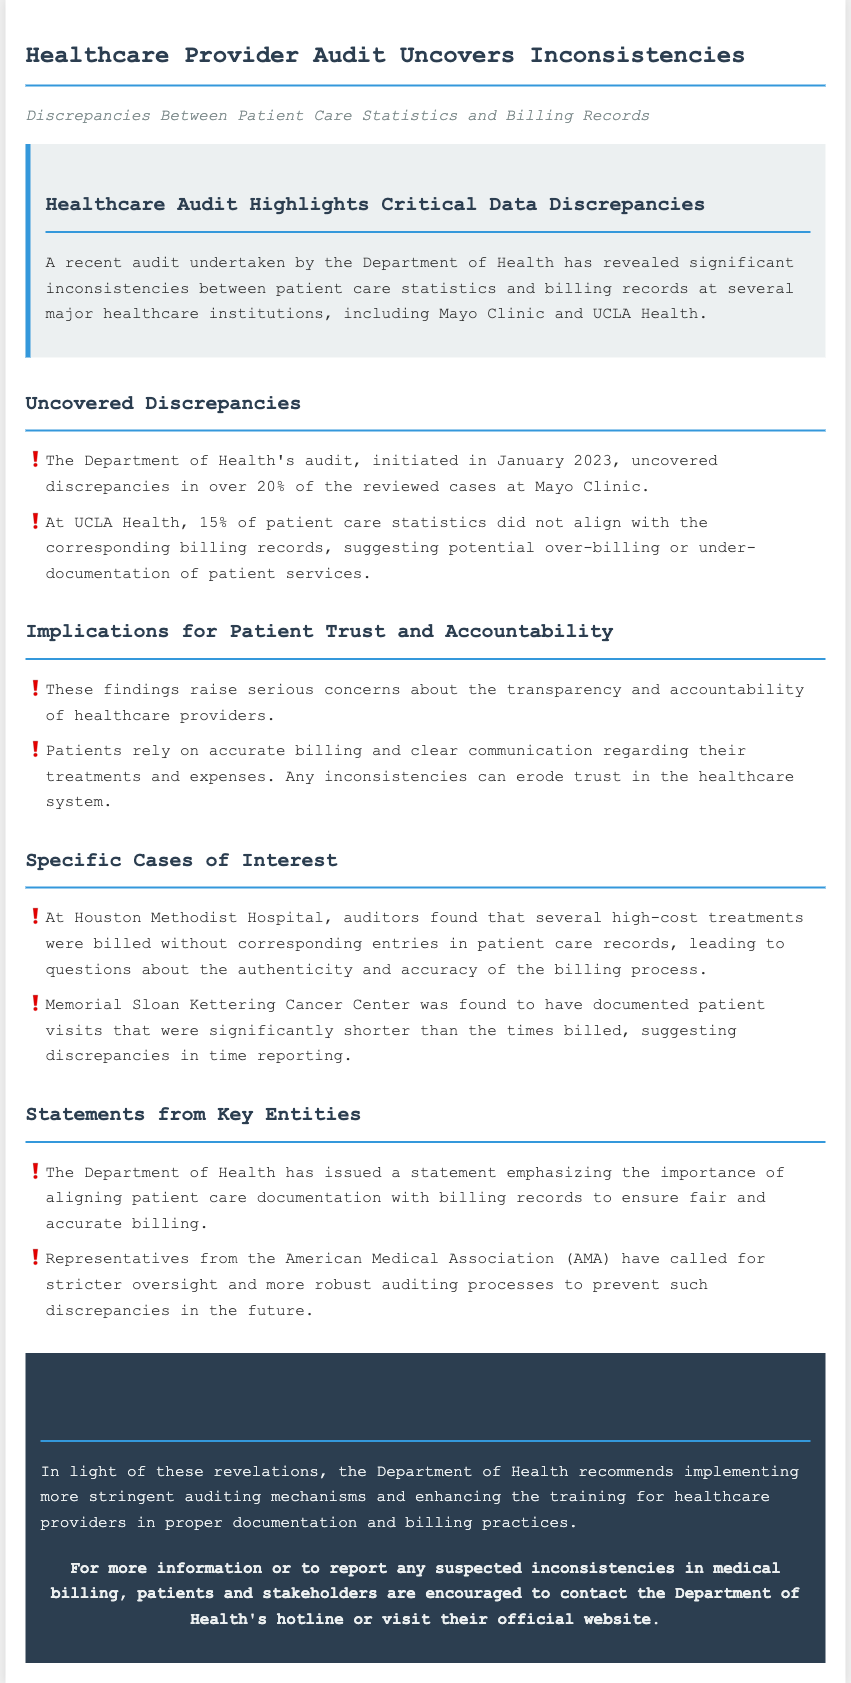What percentage of cases at Mayo Clinic had discrepancies? The document states that discrepancies were found in over 20% of the reviewed cases at Mayo Clinic.
Answer: over 20% What is the discrepancy percentage at UCLA Health? The document indicates that 15% of patient care statistics did not align with billing records at UCLA Health.
Answer: 15% Which entity issued a statement about aligning patient care documentation with billing records? The Department of Health is identified as the entity that issued a statement on the importance of aligning patient care documentation with billing records.
Answer: Department of Health What issue was highlighted at Houston Methodist Hospital? The audit found that several high-cost treatments were billed without corresponding entries in patient care records, indicating potential issues in the billing process.
Answer: High-cost treatments billed without records Which organization called for stricter oversight of healthcare providers? The American Medical Association (AMA) is noted for calling for stricter oversight and more robust auditing processes.
Answer: American Medical Association What is the recommendation made by the Department of Health? The Department of Health recommends implementing more stringent auditing mechanisms and enhancing the training for healthcare providers.
Answer: Stricter auditing mechanisms 